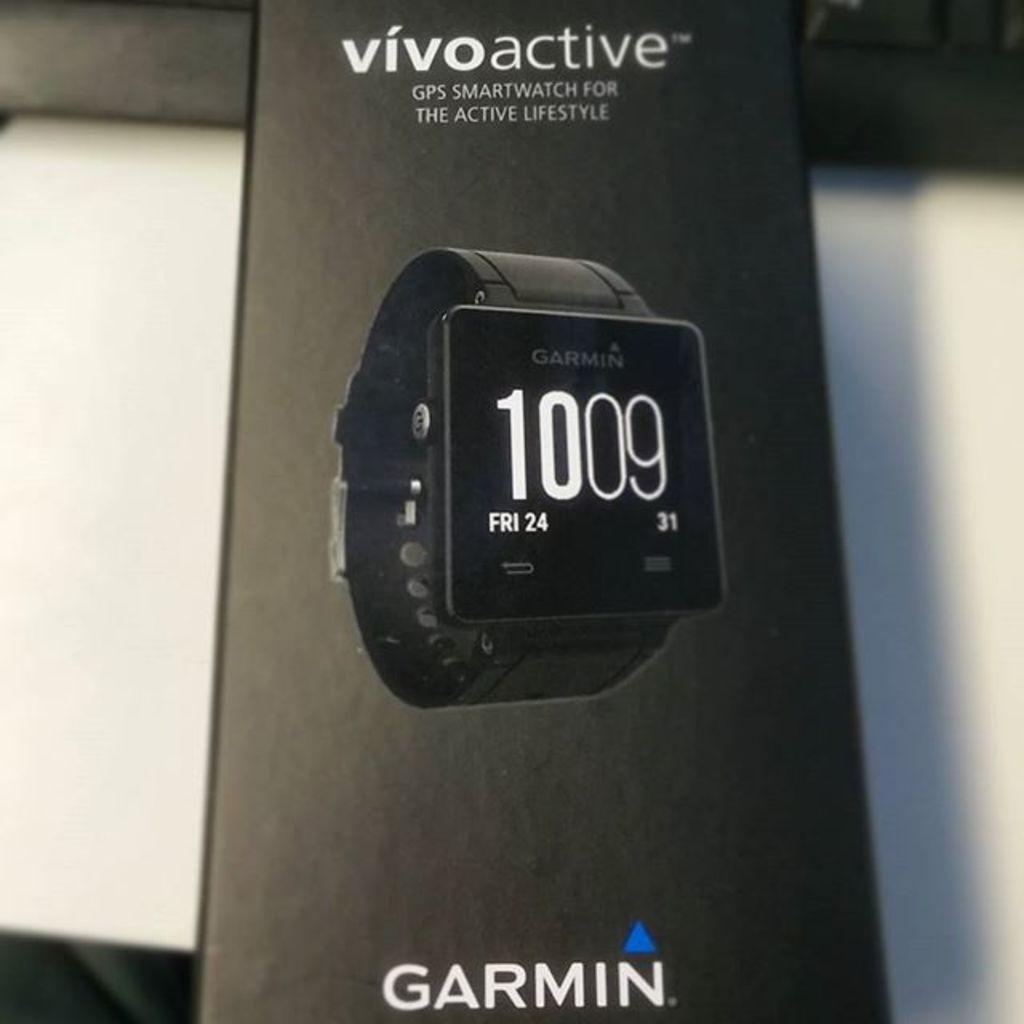Who makes the vivo active?
Provide a short and direct response. Garmin. What is the day of the week on the watch?
Offer a very short reply. Fri. 